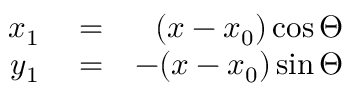<formula> <loc_0><loc_0><loc_500><loc_500>\begin{array} { r l r } { x _ { 1 } } & = } & { ( x - x _ { 0 } ) \cos \Theta } \\ { y _ { 1 } } & = } & { - ( x - x _ { 0 } ) \sin \Theta } \end{array}</formula> 